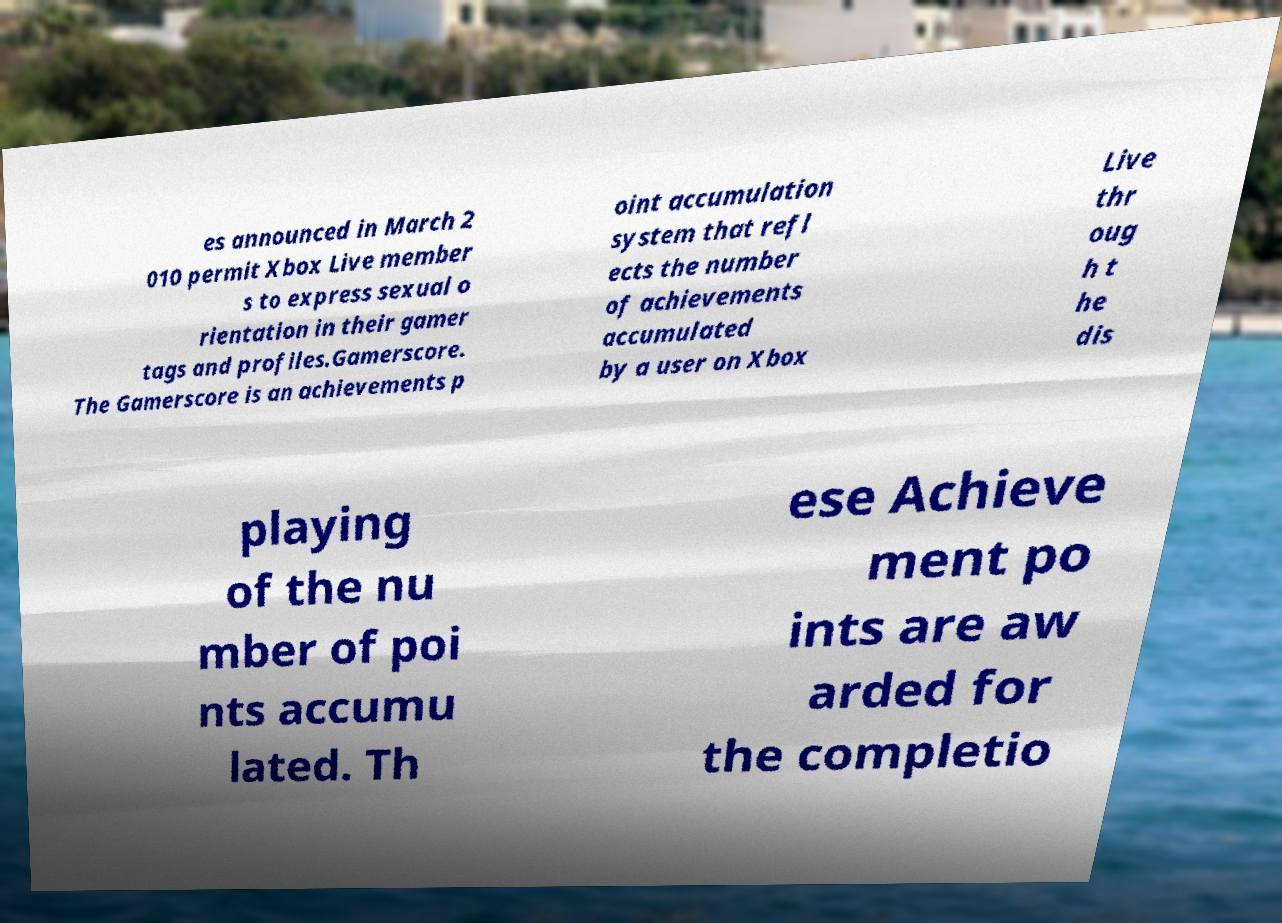Please identify and transcribe the text found in this image. es announced in March 2 010 permit Xbox Live member s to express sexual o rientation in their gamer tags and profiles.Gamerscore. The Gamerscore is an achievements p oint accumulation system that refl ects the number of achievements accumulated by a user on Xbox Live thr oug h t he dis playing of the nu mber of poi nts accumu lated. Th ese Achieve ment po ints are aw arded for the completio 